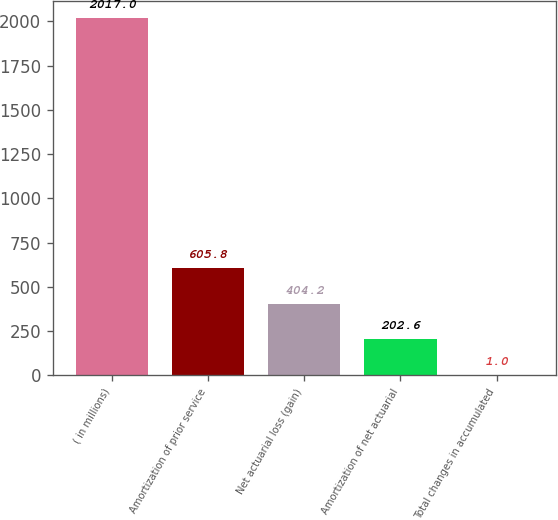<chart> <loc_0><loc_0><loc_500><loc_500><bar_chart><fcel>( in millions)<fcel>Amortization of prior service<fcel>Net actuarial loss (gain)<fcel>Amortization of net actuarial<fcel>Total changes in accumulated<nl><fcel>2017<fcel>605.8<fcel>404.2<fcel>202.6<fcel>1<nl></chart> 